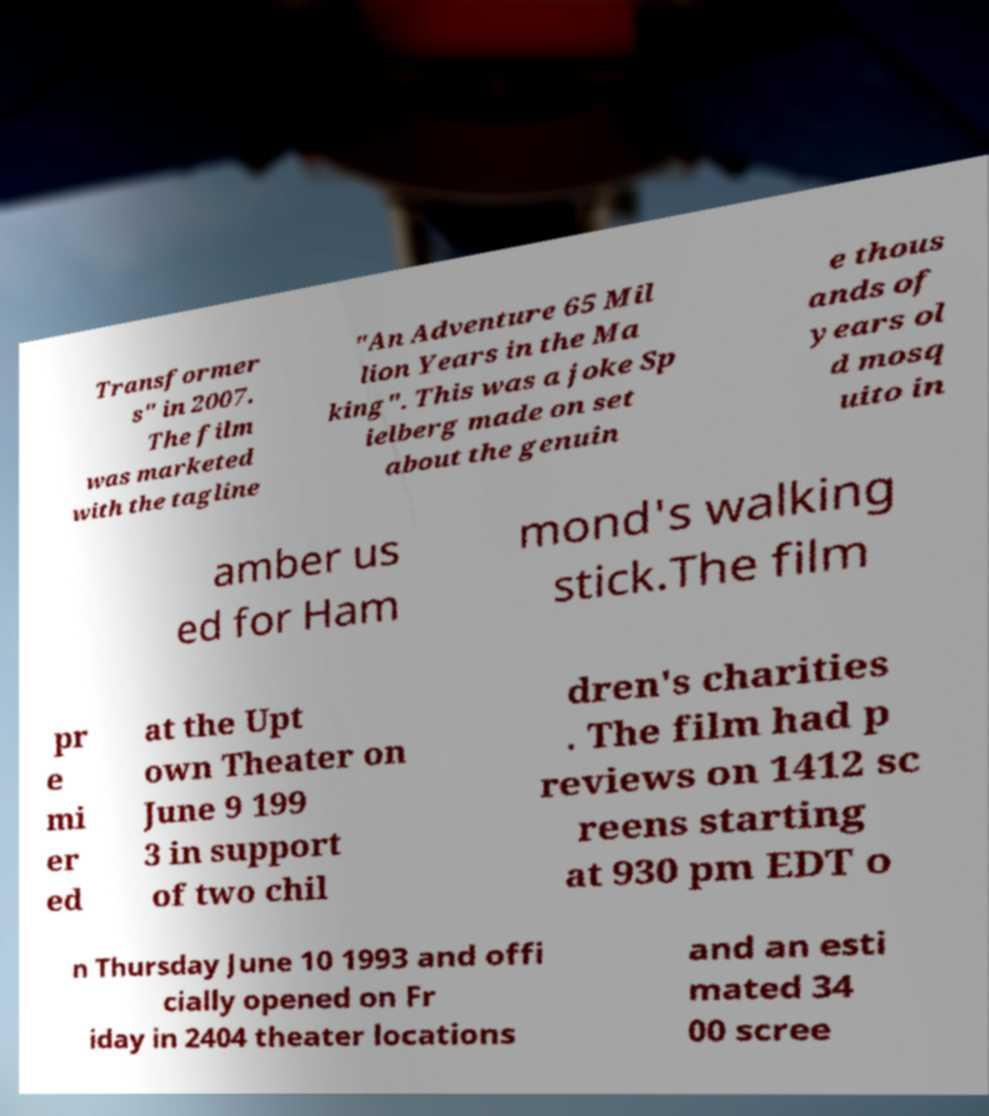What messages or text are displayed in this image? I need them in a readable, typed format. Transformer s" in 2007. The film was marketed with the tagline "An Adventure 65 Mil lion Years in the Ma king". This was a joke Sp ielberg made on set about the genuin e thous ands of years ol d mosq uito in amber us ed for Ham mond's walking stick.The film pr e mi er ed at the Upt own Theater on June 9 199 3 in support of two chil dren's charities . The film had p reviews on 1412 sc reens starting at 930 pm EDT o n Thursday June 10 1993 and offi cially opened on Fr iday in 2404 theater locations and an esti mated 34 00 scree 